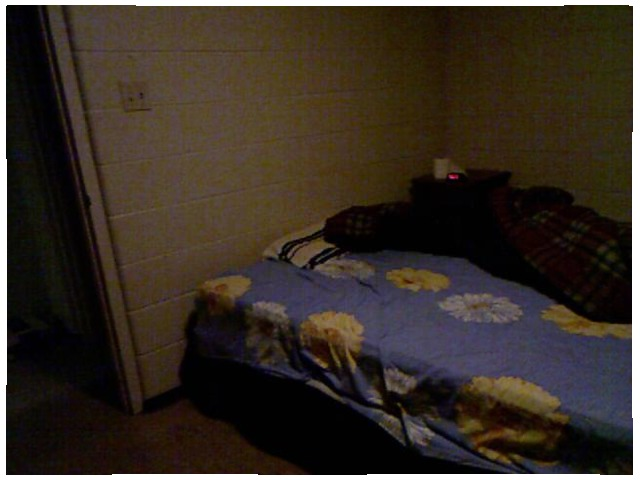<image>
Is there a jacket on the bed? Yes. Looking at the image, I can see the jacket is positioned on top of the bed, with the bed providing support. 